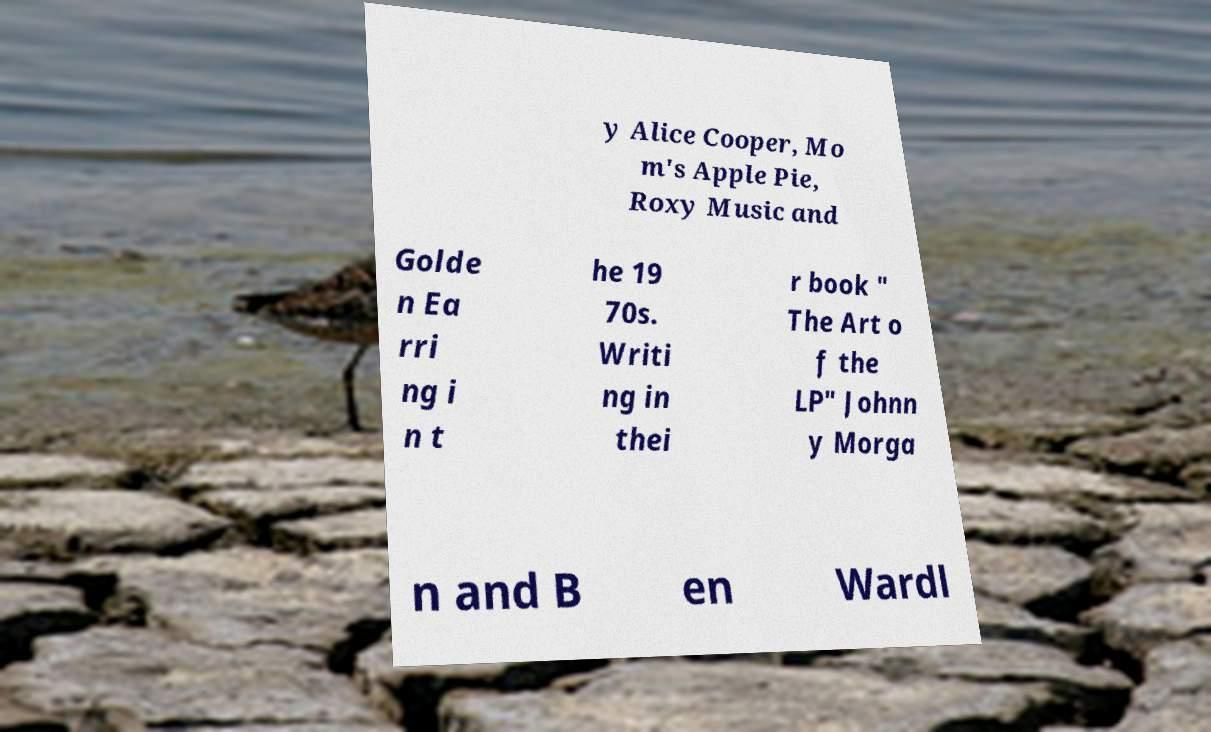There's text embedded in this image that I need extracted. Can you transcribe it verbatim? y Alice Cooper, Mo m's Apple Pie, Roxy Music and Golde n Ea rri ng i n t he 19 70s. Writi ng in thei r book " The Art o f the LP" Johnn y Morga n and B en Wardl 